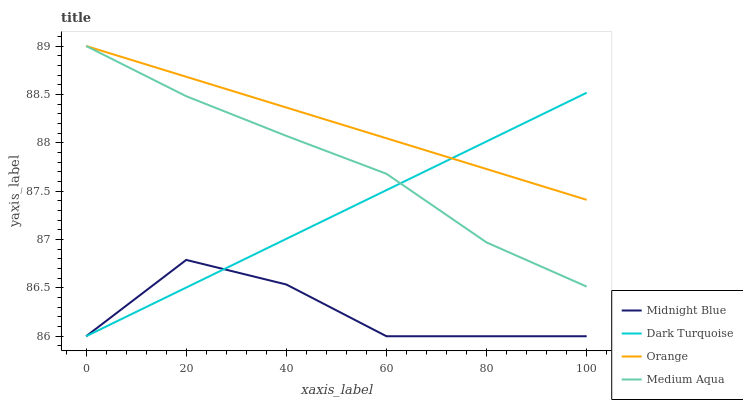Does Midnight Blue have the minimum area under the curve?
Answer yes or no. Yes. Does Orange have the maximum area under the curve?
Answer yes or no. Yes. Does Dark Turquoise have the minimum area under the curve?
Answer yes or no. No. Does Dark Turquoise have the maximum area under the curve?
Answer yes or no. No. Is Dark Turquoise the smoothest?
Answer yes or no. Yes. Is Midnight Blue the roughest?
Answer yes or no. Yes. Is Medium Aqua the smoothest?
Answer yes or no. No. Is Medium Aqua the roughest?
Answer yes or no. No. Does Medium Aqua have the lowest value?
Answer yes or no. No. Does Dark Turquoise have the highest value?
Answer yes or no. No. Is Midnight Blue less than Medium Aqua?
Answer yes or no. Yes. Is Medium Aqua greater than Midnight Blue?
Answer yes or no. Yes. Does Midnight Blue intersect Medium Aqua?
Answer yes or no. No. 